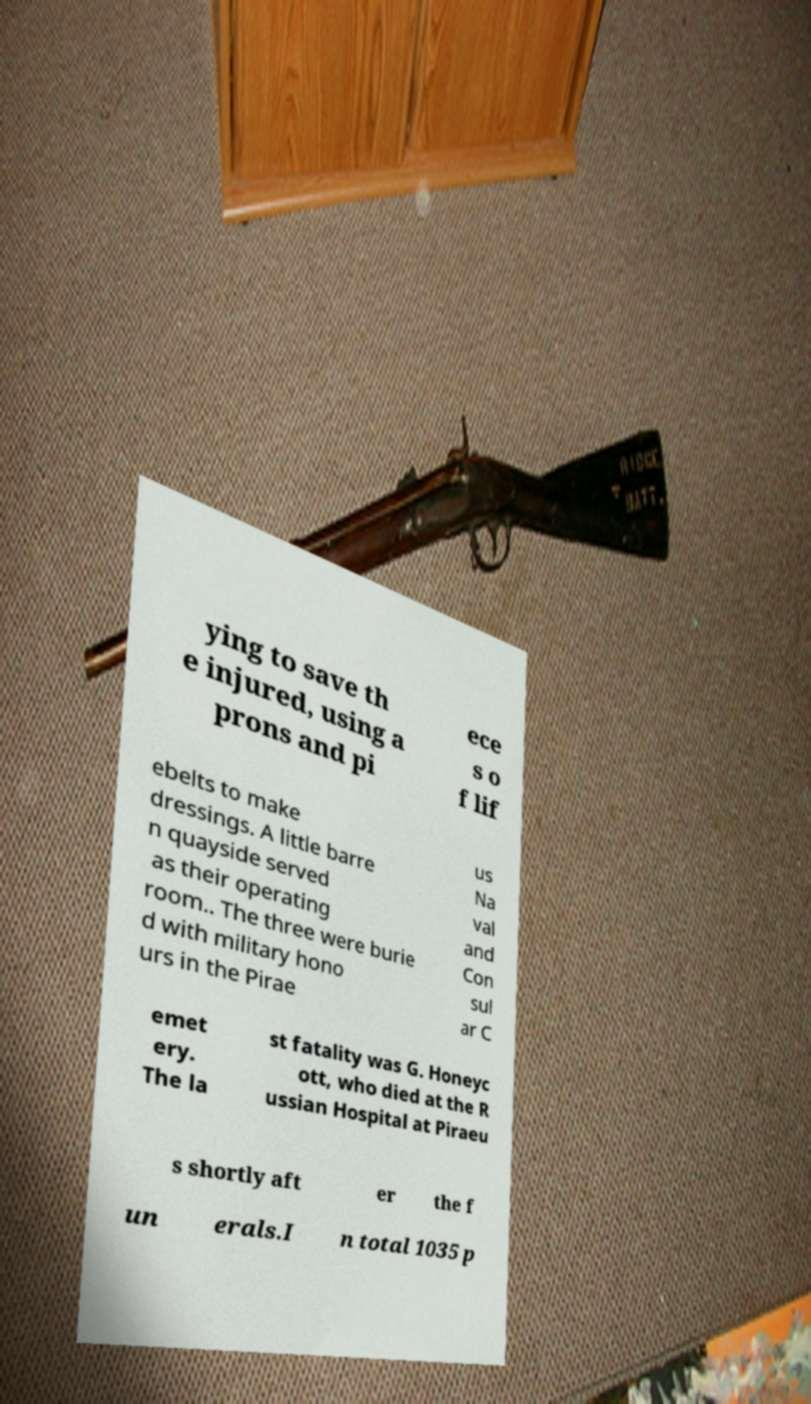Could you extract and type out the text from this image? ying to save th e injured, using a prons and pi ece s o f lif ebelts to make dressings. A little barre n quayside served as their operating room.. The three were burie d with military hono urs in the Pirae us Na val and Con sul ar C emet ery. The la st fatality was G. Honeyc ott, who died at the R ussian Hospital at Piraeu s shortly aft er the f un erals.I n total 1035 p 